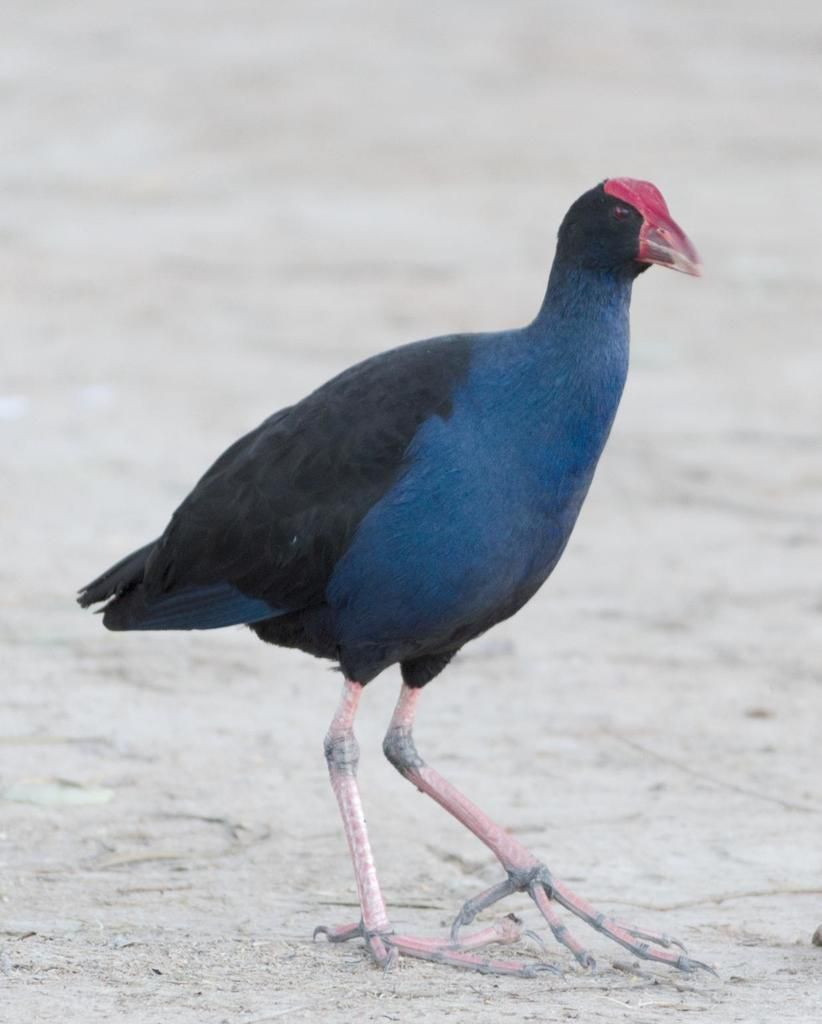What type of animal can be seen in the image? There is a bird in the image. Where is the bird located in the image? The bird is on the ground. What type of lace can be seen around the bird's throat in the image? There is no lace present around the bird's throat in the image. 